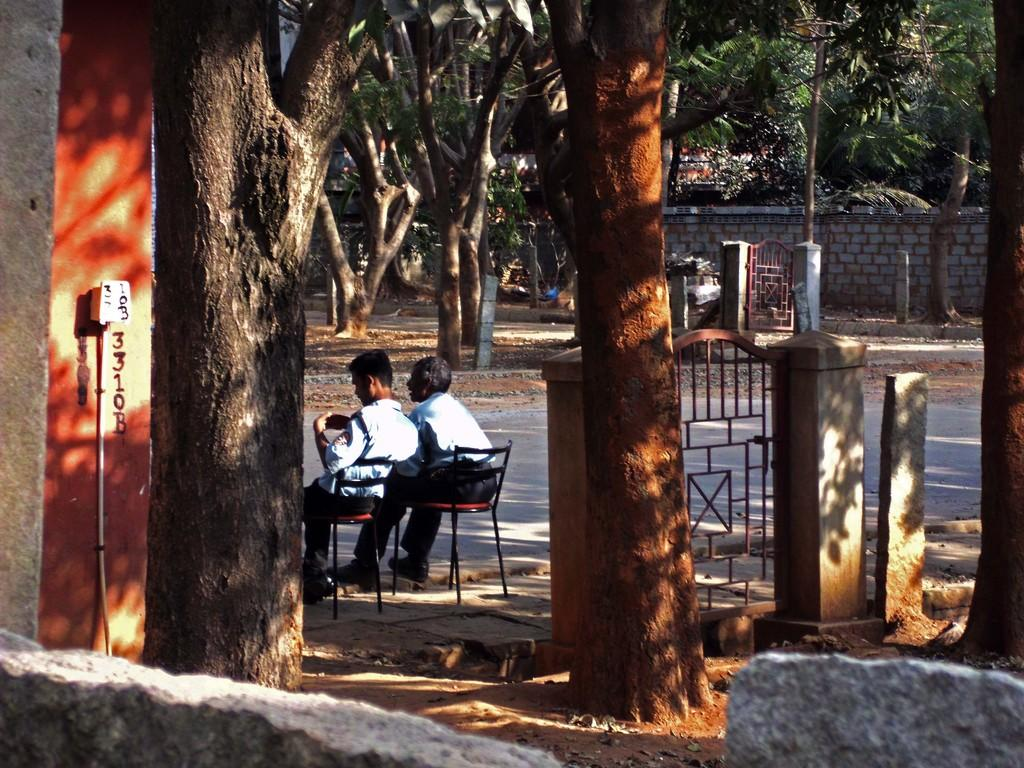What is located in the foreground of the image? In the foreground of the image, there is a wall, trees, and a gate. Can you describe the background of the image? In the background of the image, there are two men sitting on chairs, a road, poles, additional trees, another wall, and another gate. How many gates are visible in the image? There are two gates visible in the image, one in the foreground and another in the background. What type of structure can be seen in the background of the image? In the background of the image, there is another wall. How many tickets are visible in the image? There are no tickets present in the image. Are there any chickens visible in the image? There are no chickens present in the image. 